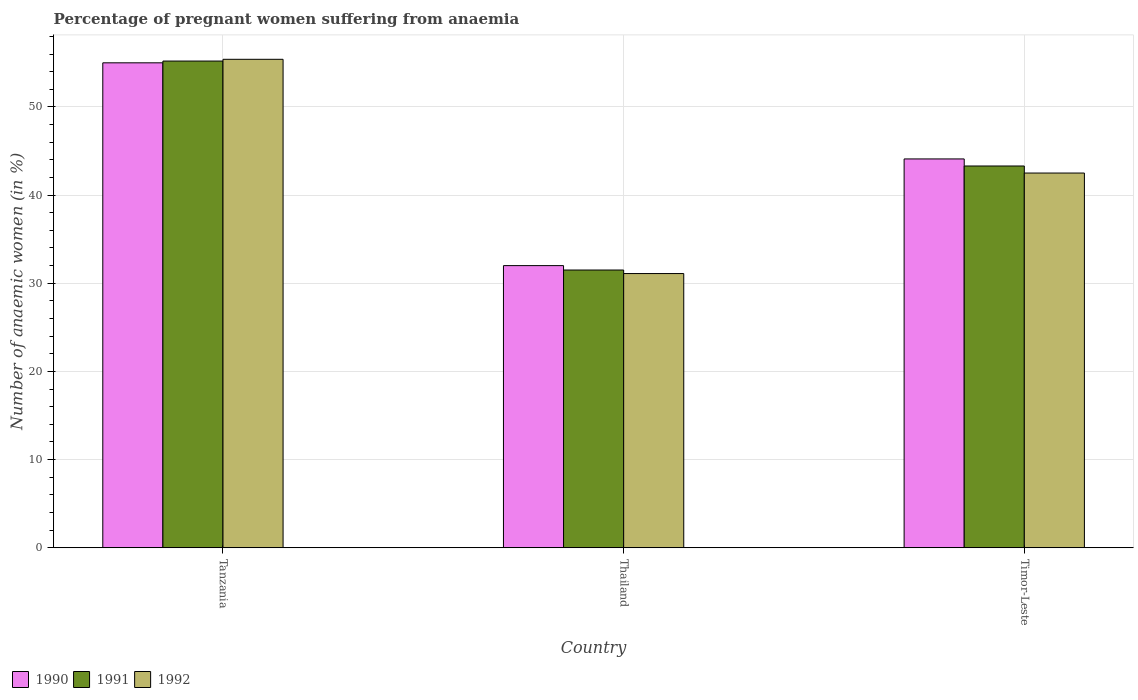How many different coloured bars are there?
Provide a succinct answer. 3. Are the number of bars on each tick of the X-axis equal?
Offer a terse response. Yes. How many bars are there on the 2nd tick from the right?
Your answer should be very brief. 3. What is the label of the 1st group of bars from the left?
Make the answer very short. Tanzania. Across all countries, what is the maximum number of anaemic women in 1992?
Ensure brevity in your answer.  55.4. In which country was the number of anaemic women in 1991 maximum?
Make the answer very short. Tanzania. In which country was the number of anaemic women in 1990 minimum?
Offer a very short reply. Thailand. What is the total number of anaemic women in 1990 in the graph?
Make the answer very short. 131.1. What is the difference between the number of anaemic women in 1990 in Thailand and that in Timor-Leste?
Your answer should be compact. -12.1. What is the difference between the number of anaemic women in 1991 in Tanzania and the number of anaemic women in 1992 in Timor-Leste?
Your response must be concise. 12.7. What is the average number of anaemic women in 1990 per country?
Your response must be concise. 43.7. What is the difference between the number of anaemic women of/in 1992 and number of anaemic women of/in 1990 in Tanzania?
Make the answer very short. 0.4. What is the ratio of the number of anaemic women in 1991 in Thailand to that in Timor-Leste?
Provide a short and direct response. 0.73. Is the number of anaemic women in 1991 in Thailand less than that in Timor-Leste?
Ensure brevity in your answer.  Yes. What is the difference between the highest and the second highest number of anaemic women in 1990?
Your response must be concise. -12.1. Is the sum of the number of anaemic women in 1991 in Tanzania and Timor-Leste greater than the maximum number of anaemic women in 1992 across all countries?
Give a very brief answer. Yes. What does the 2nd bar from the right in Timor-Leste represents?
Provide a short and direct response. 1991. Is it the case that in every country, the sum of the number of anaemic women in 1992 and number of anaemic women in 1990 is greater than the number of anaemic women in 1991?
Provide a succinct answer. Yes. How many countries are there in the graph?
Ensure brevity in your answer.  3. What is the difference between two consecutive major ticks on the Y-axis?
Your answer should be compact. 10. Are the values on the major ticks of Y-axis written in scientific E-notation?
Your response must be concise. No. Does the graph contain any zero values?
Give a very brief answer. No. Does the graph contain grids?
Keep it short and to the point. Yes. Where does the legend appear in the graph?
Give a very brief answer. Bottom left. What is the title of the graph?
Your response must be concise. Percentage of pregnant women suffering from anaemia. Does "2015" appear as one of the legend labels in the graph?
Your response must be concise. No. What is the label or title of the X-axis?
Give a very brief answer. Country. What is the label or title of the Y-axis?
Your answer should be compact. Number of anaemic women (in %). What is the Number of anaemic women (in %) of 1991 in Tanzania?
Provide a short and direct response. 55.2. What is the Number of anaemic women (in %) in 1992 in Tanzania?
Provide a short and direct response. 55.4. What is the Number of anaemic women (in %) of 1990 in Thailand?
Make the answer very short. 32. What is the Number of anaemic women (in %) in 1991 in Thailand?
Make the answer very short. 31.5. What is the Number of anaemic women (in %) in 1992 in Thailand?
Offer a terse response. 31.1. What is the Number of anaemic women (in %) of 1990 in Timor-Leste?
Offer a terse response. 44.1. What is the Number of anaemic women (in %) in 1991 in Timor-Leste?
Ensure brevity in your answer.  43.3. What is the Number of anaemic women (in %) in 1992 in Timor-Leste?
Your response must be concise. 42.5. Across all countries, what is the maximum Number of anaemic women (in %) in 1990?
Your response must be concise. 55. Across all countries, what is the maximum Number of anaemic women (in %) of 1991?
Offer a terse response. 55.2. Across all countries, what is the maximum Number of anaemic women (in %) of 1992?
Offer a terse response. 55.4. Across all countries, what is the minimum Number of anaemic women (in %) of 1991?
Provide a succinct answer. 31.5. Across all countries, what is the minimum Number of anaemic women (in %) of 1992?
Make the answer very short. 31.1. What is the total Number of anaemic women (in %) in 1990 in the graph?
Your answer should be compact. 131.1. What is the total Number of anaemic women (in %) of 1991 in the graph?
Give a very brief answer. 130. What is the total Number of anaemic women (in %) of 1992 in the graph?
Make the answer very short. 129. What is the difference between the Number of anaemic women (in %) in 1991 in Tanzania and that in Thailand?
Your answer should be very brief. 23.7. What is the difference between the Number of anaemic women (in %) of 1992 in Tanzania and that in Thailand?
Your answer should be very brief. 24.3. What is the difference between the Number of anaemic women (in %) of 1990 in Tanzania and that in Timor-Leste?
Keep it short and to the point. 10.9. What is the difference between the Number of anaemic women (in %) in 1992 in Tanzania and that in Timor-Leste?
Your answer should be compact. 12.9. What is the difference between the Number of anaemic women (in %) in 1991 in Thailand and that in Timor-Leste?
Your response must be concise. -11.8. What is the difference between the Number of anaemic women (in %) in 1990 in Tanzania and the Number of anaemic women (in %) in 1991 in Thailand?
Give a very brief answer. 23.5. What is the difference between the Number of anaemic women (in %) of 1990 in Tanzania and the Number of anaemic women (in %) of 1992 in Thailand?
Ensure brevity in your answer.  23.9. What is the difference between the Number of anaemic women (in %) of 1991 in Tanzania and the Number of anaemic women (in %) of 1992 in Thailand?
Offer a very short reply. 24.1. What is the difference between the Number of anaemic women (in %) in 1990 in Tanzania and the Number of anaemic women (in %) in 1991 in Timor-Leste?
Offer a terse response. 11.7. What is the difference between the Number of anaemic women (in %) of 1991 in Tanzania and the Number of anaemic women (in %) of 1992 in Timor-Leste?
Provide a succinct answer. 12.7. What is the difference between the Number of anaemic women (in %) in 1990 in Thailand and the Number of anaemic women (in %) in 1992 in Timor-Leste?
Offer a terse response. -10.5. What is the average Number of anaemic women (in %) of 1990 per country?
Offer a very short reply. 43.7. What is the average Number of anaemic women (in %) in 1991 per country?
Give a very brief answer. 43.33. What is the difference between the Number of anaemic women (in %) in 1990 and Number of anaemic women (in %) in 1991 in Timor-Leste?
Offer a terse response. 0.8. What is the difference between the Number of anaemic women (in %) of 1991 and Number of anaemic women (in %) of 1992 in Timor-Leste?
Make the answer very short. 0.8. What is the ratio of the Number of anaemic women (in %) of 1990 in Tanzania to that in Thailand?
Give a very brief answer. 1.72. What is the ratio of the Number of anaemic women (in %) in 1991 in Tanzania to that in Thailand?
Your answer should be compact. 1.75. What is the ratio of the Number of anaemic women (in %) in 1992 in Tanzania to that in Thailand?
Offer a very short reply. 1.78. What is the ratio of the Number of anaemic women (in %) in 1990 in Tanzania to that in Timor-Leste?
Your response must be concise. 1.25. What is the ratio of the Number of anaemic women (in %) in 1991 in Tanzania to that in Timor-Leste?
Ensure brevity in your answer.  1.27. What is the ratio of the Number of anaemic women (in %) in 1992 in Tanzania to that in Timor-Leste?
Provide a succinct answer. 1.3. What is the ratio of the Number of anaemic women (in %) of 1990 in Thailand to that in Timor-Leste?
Give a very brief answer. 0.73. What is the ratio of the Number of anaemic women (in %) of 1991 in Thailand to that in Timor-Leste?
Offer a terse response. 0.73. What is the ratio of the Number of anaemic women (in %) in 1992 in Thailand to that in Timor-Leste?
Provide a succinct answer. 0.73. What is the difference between the highest and the second highest Number of anaemic women (in %) in 1991?
Ensure brevity in your answer.  11.9. What is the difference between the highest and the second highest Number of anaemic women (in %) of 1992?
Your answer should be very brief. 12.9. What is the difference between the highest and the lowest Number of anaemic women (in %) of 1990?
Give a very brief answer. 23. What is the difference between the highest and the lowest Number of anaemic women (in %) in 1991?
Your response must be concise. 23.7. What is the difference between the highest and the lowest Number of anaemic women (in %) of 1992?
Your answer should be very brief. 24.3. 